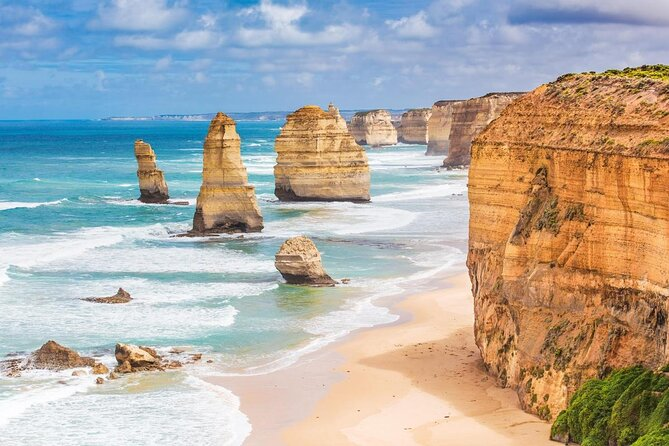Imagine a fantasy story set in this location. In a land where the ocean whispers ancient secrets and the sky weaves tales of forgotten glory, the twelve limestone pillars known as the Twelve Apostles are more than mere rock formations—they are the sentinels of the realm of Aeloria. Legend has it that these towering stacks were once mighty guardians, turned to stone by a powerful enchantress to protect the shores from the encroaching void. Every century, when the moon aligns with the sun in a celestial dance, the guardians awaken, if only for a night. On this mystical evening, the sea sparkles with bioluminescent life, and the air is thick with magic. It's said that those brave enough to walk the shores during this fateful night can seek the counsel of the guardians, who possess wisdom beyond mortal comprehension. Follow the story of Elara, a skilled navigator and the last of the Star Nomads, as she embarks on a quest to uncover these timeless secrets and restore balance to her world. 